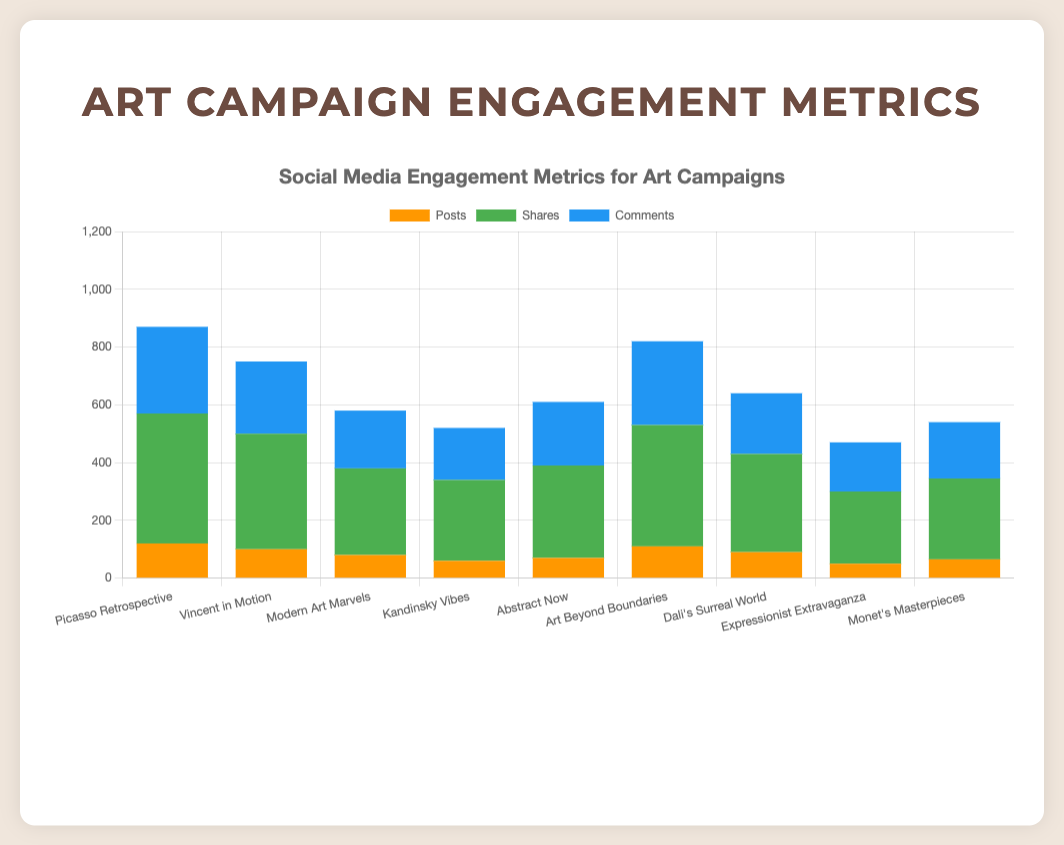What is the total number of posts for all art campaigns? To find the total number of posts, sum the posts from each campaign: 120 + 100 + 80 + 60 + 70 + 110 + 90 + 50 + 65 = 745
Answer: 745 Which art campaign received the highest number of shares on Instagram? Compare the shares of Instagram campaigns: "Picasso Retrospective" (450), "Vincent in Motion" (400), "Art Beyond Boundaries" (420). "Picasso Retrospective" has the highest number of shares.
Answer: Picasso Retrospective What is the difference in the number of shares between the "Kandinsky Vibes" campaign on Twitter and the "Dali's Surreal World" campaign on Facebook? Subtract the number of shares of "Dali's Surreal World" (340) from "Kandinsky Vibes" (280): 280 - 340 = -60
Answer: -60 How does the number of comments for the "Vincent in Motion" campaign compare to the number of comments for the "Abstract Now" campaign? Compare the number of comments: "Vincent in Motion" received 250 comments while "Abstract Now" received 220 comments. So, "Vincent in Motion" has more comments.
Answer: Vincent in Motion has more comments Which campaign has the fewest total engagement metrics (sum of posts, shares, comments)? Calculate the total engagement for each campaign:  
1. "Picasso Retrospective": 120 + 450 + 300 = 870  
2. "Vincent in Motion": 100 + 400 + 250 = 750  
3. "Modern Art Marvels": 80 + 300 + 200 = 580  
4. "Kandinsky Vibes": 60 + 280 + 180 = 520  
5. "Abstract Now": 70 + 320 + 220 = 610  
6. "Art Beyond Boundaries": 110 + 420 + 290 = 820  
7. "Dali's Surreal World": 90 + 340 + 210 = 640  
8. "Expressionist Extravaganza": 50 + 250 + 170 = 470  
9. "Monet's Masterpieces": 65 + 280 + 195 = 540  
"Expressionist Extravaganza" has the fewest total engagement metrics.
Answer: Expressionist Extravaganza How many more posts does the "Picasso Retrospective" campaign have compared to the "Expressionist Extravaganza" campaign? Subtract the number of posts in "Expressionist Extravaganza" (50) from the number of posts in "Picasso Retrospective" (120): 120 - 50 = 70
Answer: 70 What is the average number of shares across all campaigns on all platforms? Calculate the average by summing all shares and dividing by the number of campaigns:  
(450 + 400 + 300 + 280 + 320 + 420 + 340 + 250 + 280) / 9  
= 3040 / 9 ≈ 337.78
Answer: 337.78 